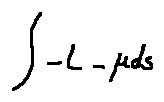<formula> <loc_0><loc_0><loc_500><loc_500>\int - L - \mu d s</formula> 